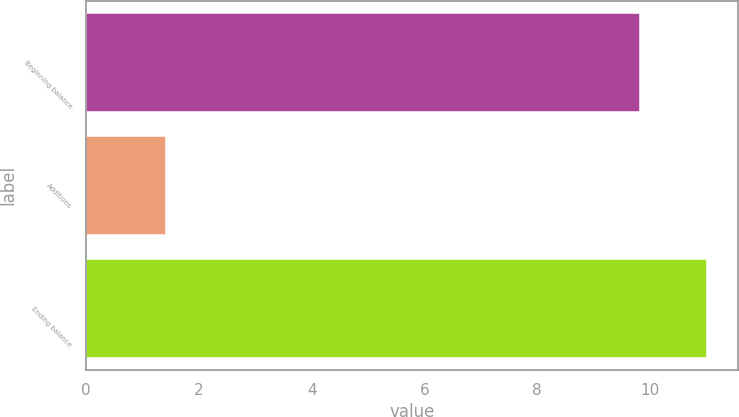Convert chart. <chart><loc_0><loc_0><loc_500><loc_500><bar_chart><fcel>Beginning balance<fcel>Additions<fcel>Ending balance<nl><fcel>9.8<fcel>1.4<fcel>11<nl></chart> 